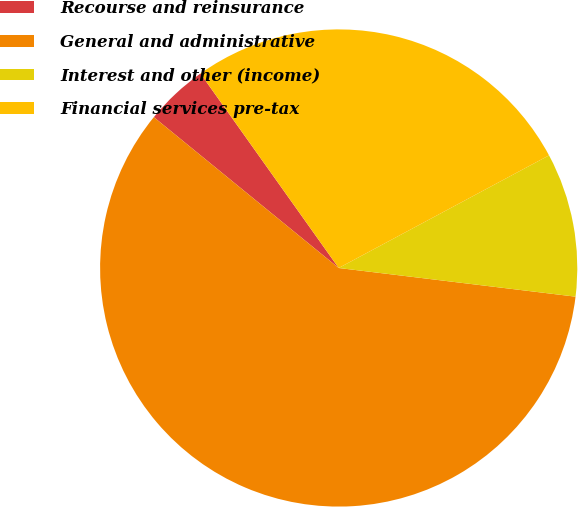Convert chart to OTSL. <chart><loc_0><loc_0><loc_500><loc_500><pie_chart><fcel>Recourse and reinsurance<fcel>General and administrative<fcel>Interest and other (income)<fcel>Financial services pre-tax<nl><fcel>4.27%<fcel>58.97%<fcel>9.74%<fcel>27.01%<nl></chart> 